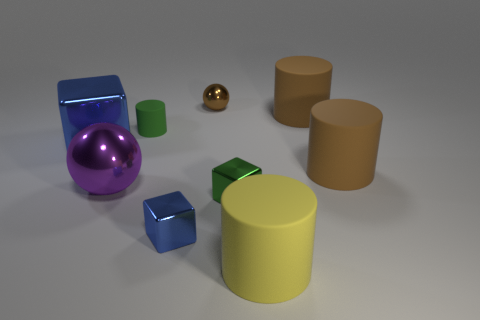What number of things are on the right side of the large metal block and left of the tiny brown metallic sphere?
Your response must be concise. 3. What is the material of the tiny green object that is right of the small matte object?
Keep it short and to the point. Metal. The purple object that is the same material as the brown sphere is what size?
Your answer should be compact. Large. Are there any tiny cylinders to the right of the tiny brown metal ball?
Ensure brevity in your answer.  No. What size is the green metallic object that is the same shape as the small blue metallic object?
Your answer should be compact. Small. There is a tiny matte thing; does it have the same color as the block on the right side of the brown metallic object?
Keep it short and to the point. Yes. Does the tiny matte cylinder have the same color as the large metal cube?
Make the answer very short. No. Are there fewer green matte objects than blue shiny blocks?
Offer a very short reply. Yes. What number of other things are there of the same color as the big metal ball?
Your response must be concise. 0. What number of large brown objects are there?
Ensure brevity in your answer.  2. 